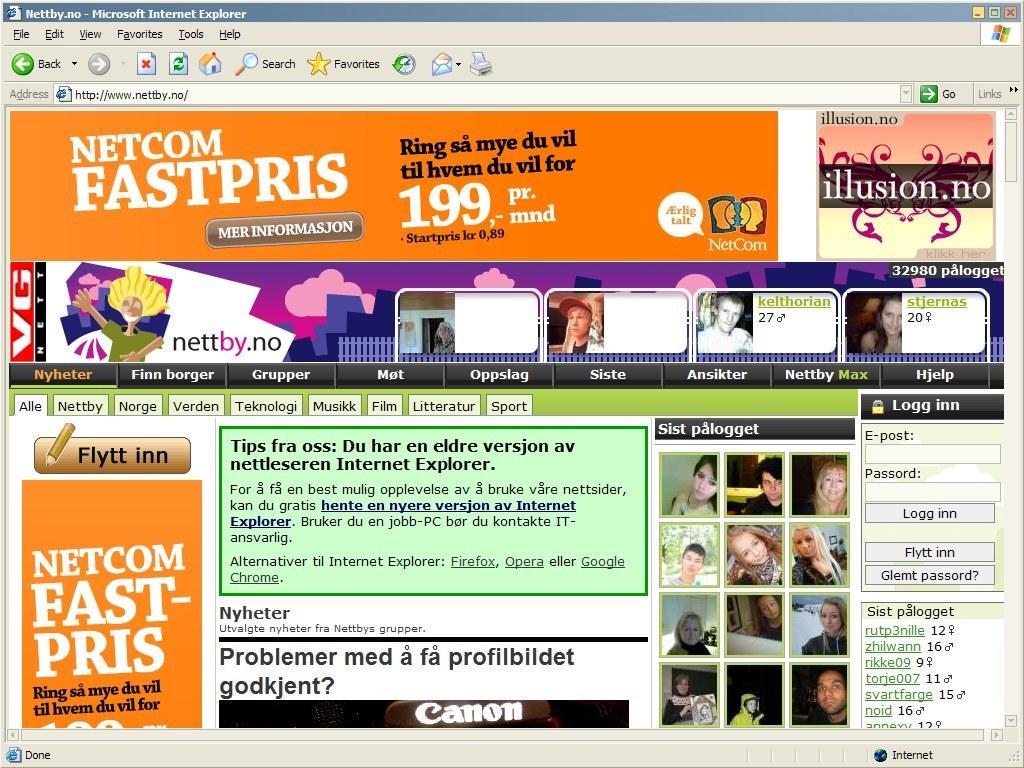What type of characters are present in the image? There are animated persons in the image. What else can be found in the image besides the animated characters? There is text in the image. How many geese are present in the image? There are no geese present in the image; it features animated persons and text. What type of box is visible in the image? There is no box present in the image. 